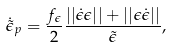Convert formula to latex. <formula><loc_0><loc_0><loc_500><loc_500>\dot { \tilde { \epsilon } } _ { p } = \frac { f _ { \epsilon } } 2 \frac { | | \dot { \epsilon } \epsilon | | + | | \epsilon \dot { \epsilon } | | } { \tilde { \epsilon } } ,</formula> 